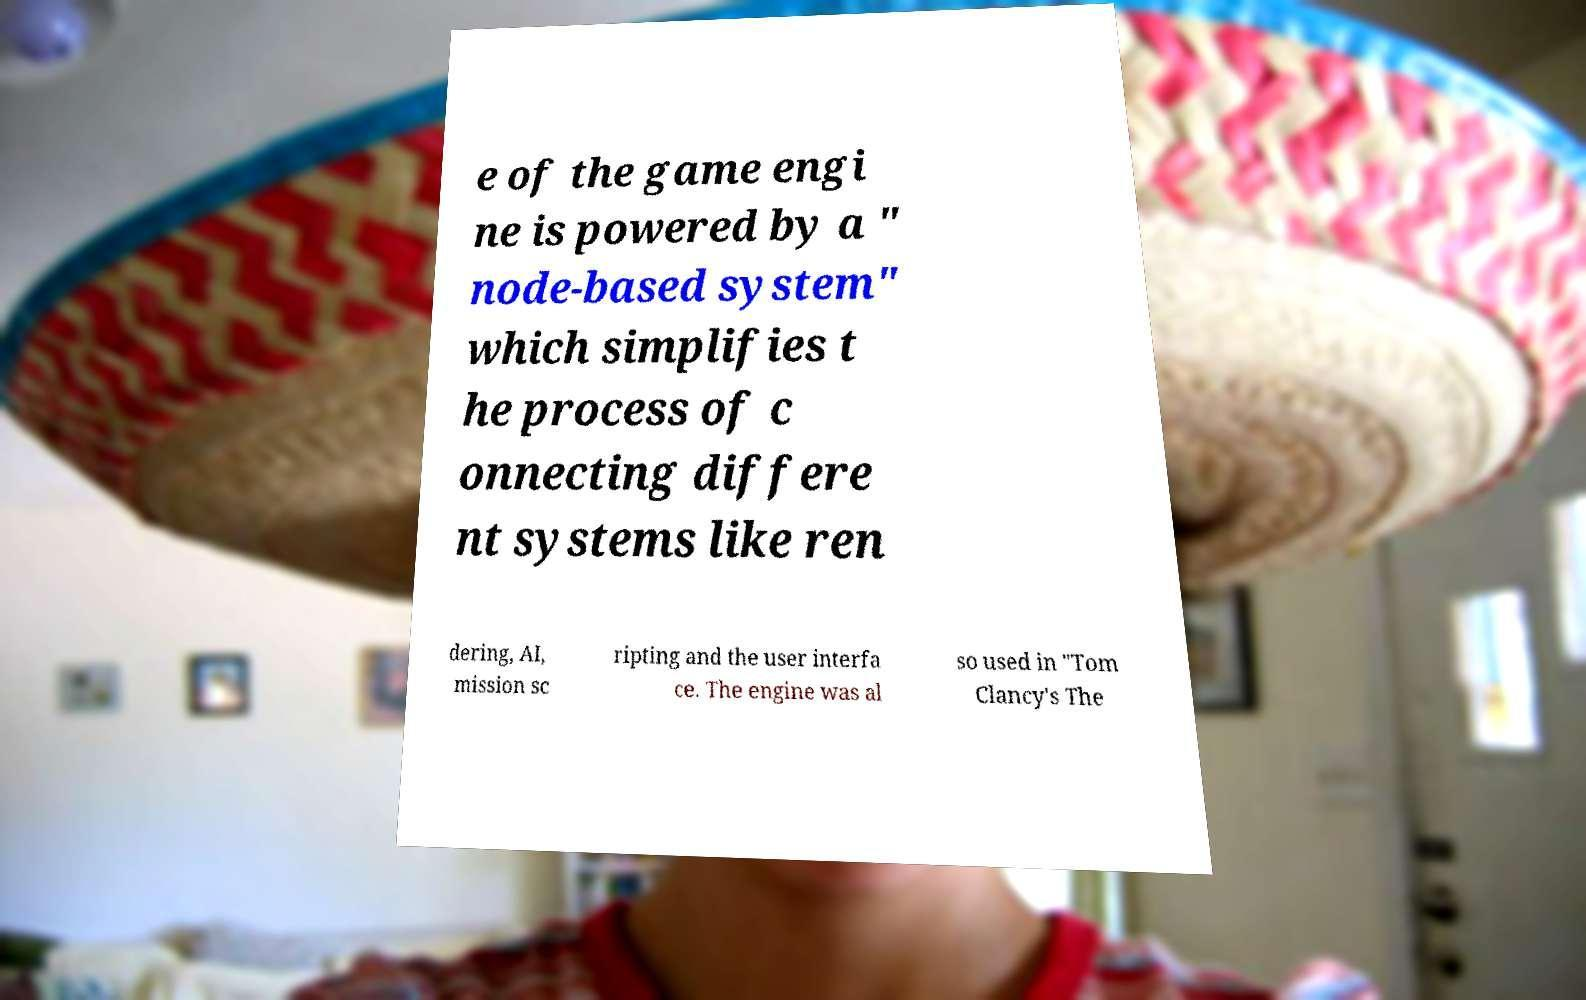What messages or text are displayed in this image? I need them in a readable, typed format. e of the game engi ne is powered by a " node-based system" which simplifies t he process of c onnecting differe nt systems like ren dering, AI, mission sc ripting and the user interfa ce. The engine was al so used in "Tom Clancy's The 